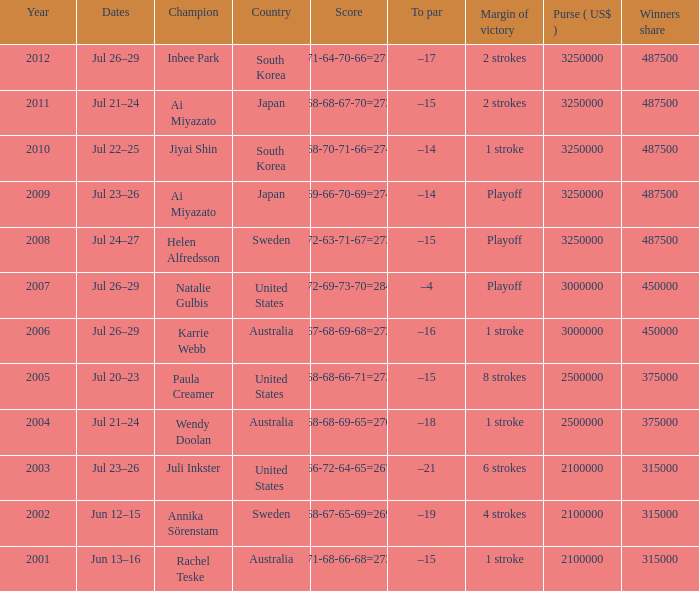What is the earliest year listed? 2001.0. 